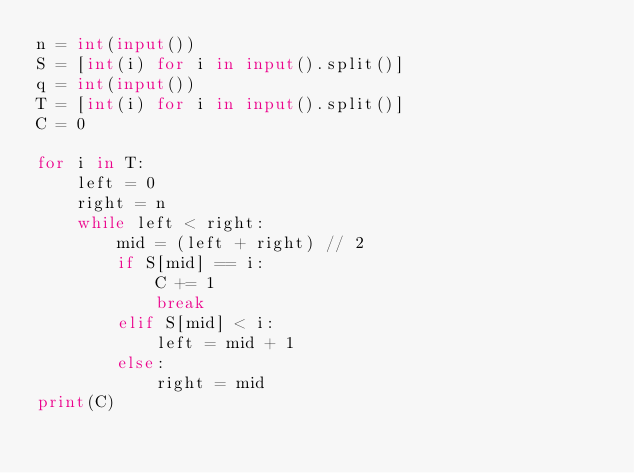<code> <loc_0><loc_0><loc_500><loc_500><_Python_>n = int(input())
S = [int(i) for i in input().split()]
q = int(input())
T = [int(i) for i in input().split()]
C = 0

for i in T:
    left = 0
    right = n
    while left < right:
        mid = (left + right) // 2
        if S[mid] == i:
            C += 1
            break
        elif S[mid] < i:
            left = mid + 1 
        else:
            right = mid
print(C)</code> 